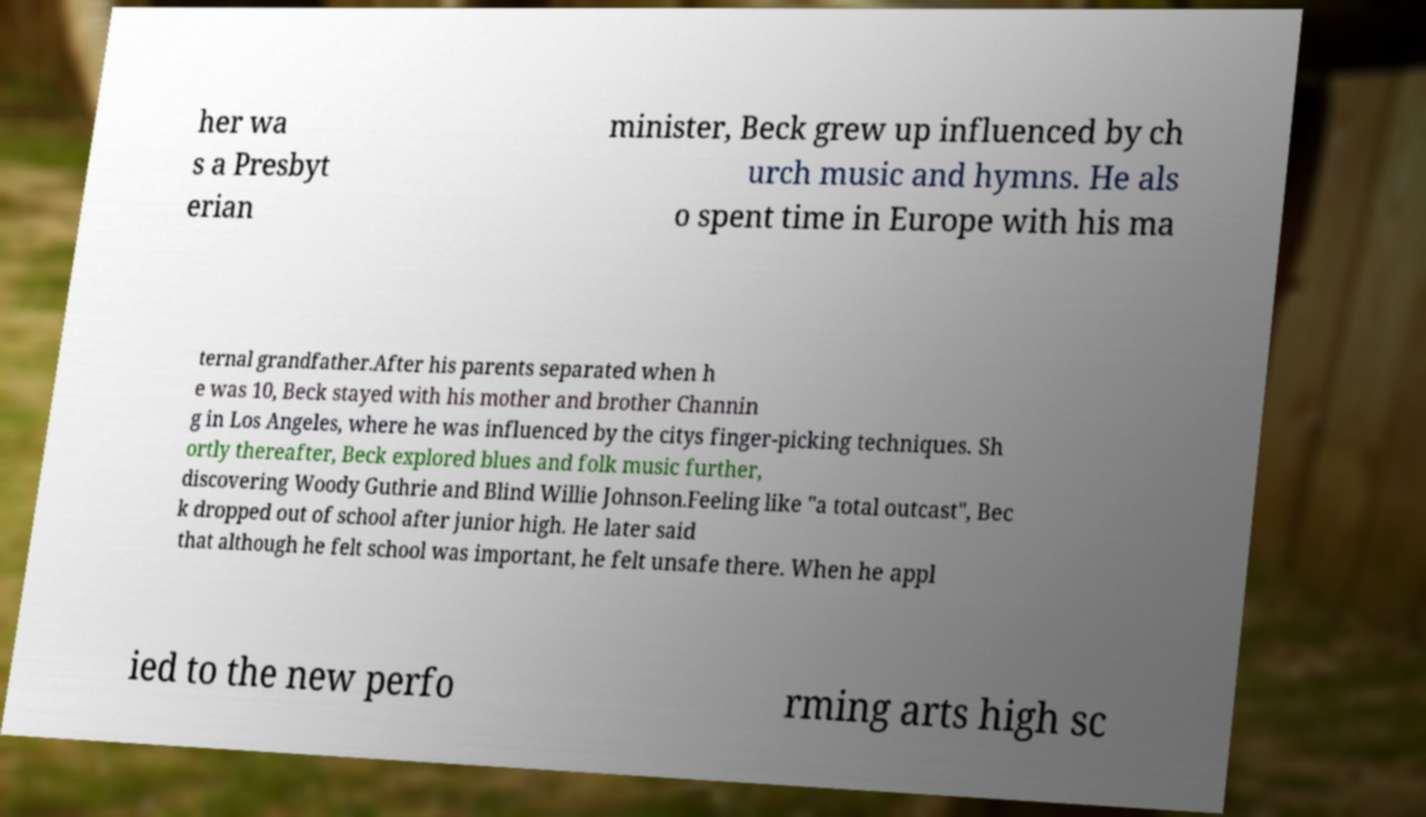There's text embedded in this image that I need extracted. Can you transcribe it verbatim? her wa s a Presbyt erian minister, Beck grew up influenced by ch urch music and hymns. He als o spent time in Europe with his ma ternal grandfather.After his parents separated when h e was 10, Beck stayed with his mother and brother Channin g in Los Angeles, where he was influenced by the citys finger-picking techniques. Sh ortly thereafter, Beck explored blues and folk music further, discovering Woody Guthrie and Blind Willie Johnson.Feeling like "a total outcast", Bec k dropped out of school after junior high. He later said that although he felt school was important, he felt unsafe there. When he appl ied to the new perfo rming arts high sc 